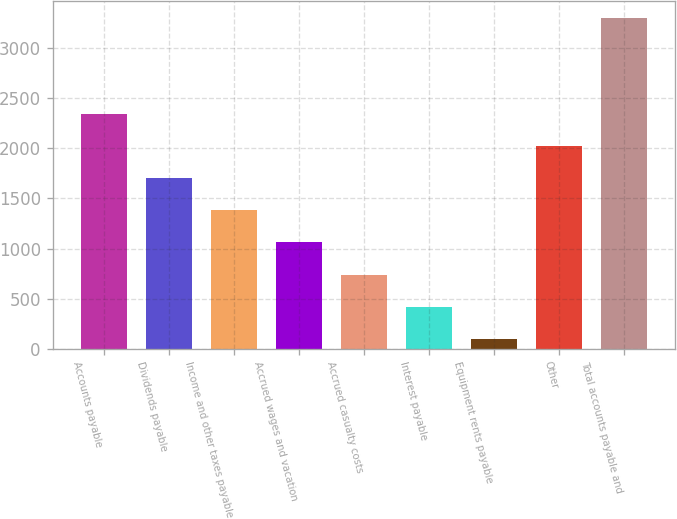<chart> <loc_0><loc_0><loc_500><loc_500><bar_chart><fcel>Accounts payable<fcel>Dividends payable<fcel>Income and other taxes payable<fcel>Accrued wages and vacation<fcel>Accrued casualty costs<fcel>Interest payable<fcel>Equipment rents payable<fcel>Other<fcel>Total accounts payable and<nl><fcel>2342.1<fcel>1701.5<fcel>1381.2<fcel>1060.9<fcel>740.6<fcel>420.3<fcel>100<fcel>2021.8<fcel>3303<nl></chart> 